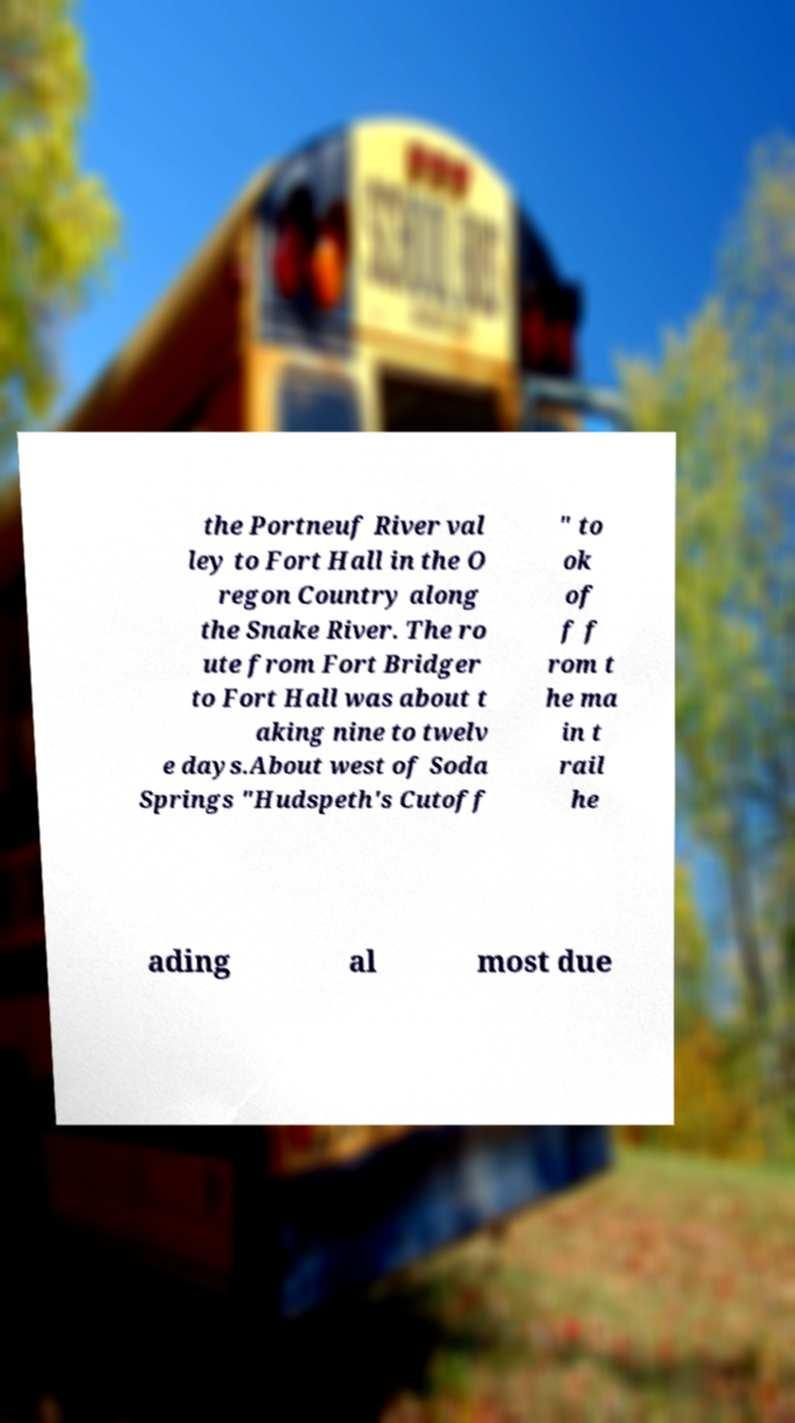Could you extract and type out the text from this image? the Portneuf River val ley to Fort Hall in the O regon Country along the Snake River. The ro ute from Fort Bridger to Fort Hall was about t aking nine to twelv e days.About west of Soda Springs "Hudspeth's Cutoff " to ok of f f rom t he ma in t rail he ading al most due 